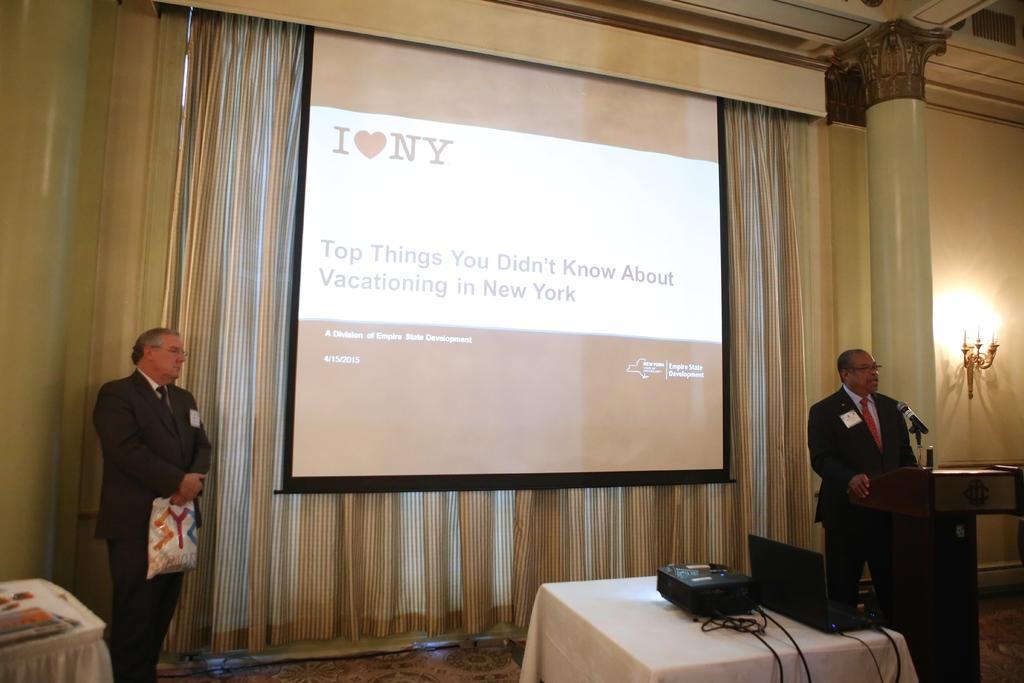Could you give a brief overview of what you see in this image? In this image in this room the two persons are standing on the floor something is there and also table is also there. 